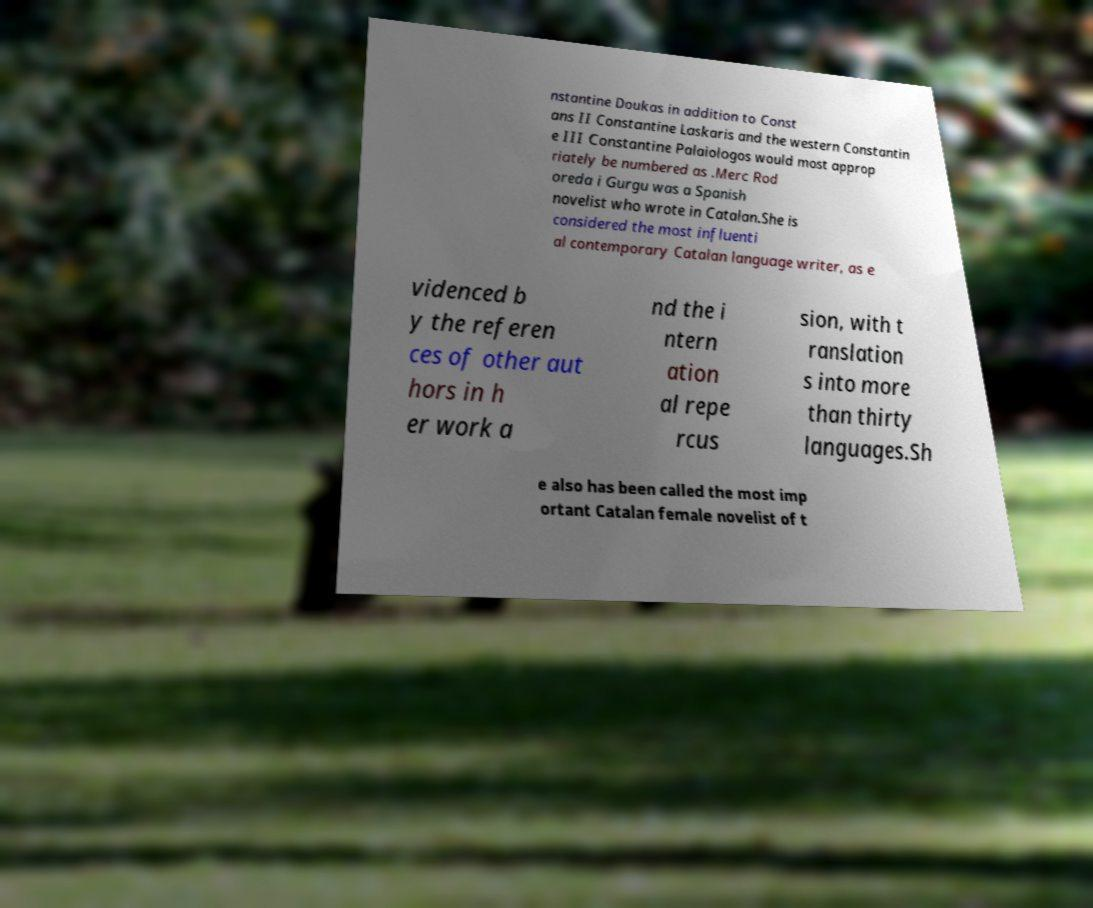Can you read and provide the text displayed in the image?This photo seems to have some interesting text. Can you extract and type it out for me? nstantine Doukas in addition to Const ans II Constantine Laskaris and the western Constantin e III Constantine Palaiologos would most approp riately be numbered as .Merc Rod oreda i Gurgu was a Spanish novelist who wrote in Catalan.She is considered the most influenti al contemporary Catalan language writer, as e videnced b y the referen ces of other aut hors in h er work a nd the i ntern ation al repe rcus sion, with t ranslation s into more than thirty languages.Sh e also has been called the most imp ortant Catalan female novelist of t 